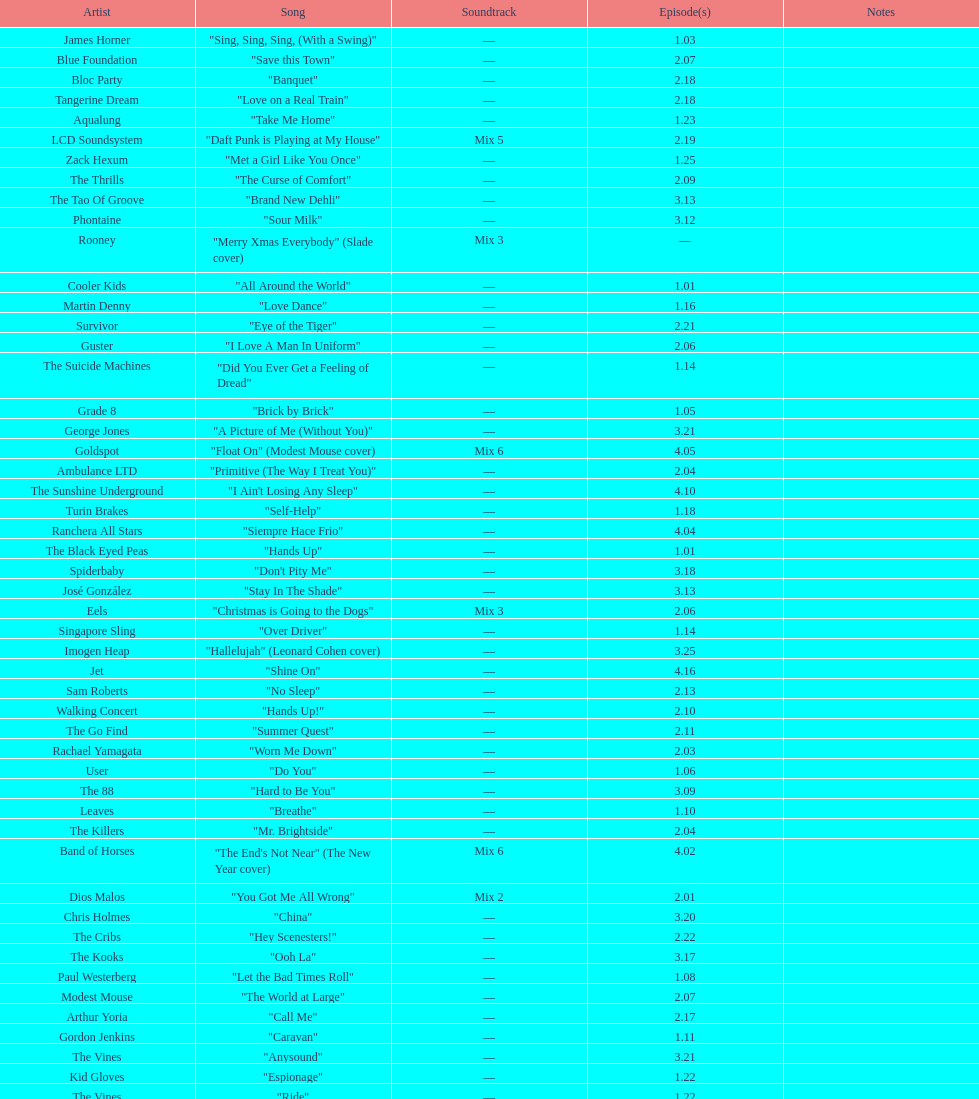"girl" and "el pro" were performed by which artist? Beck. 